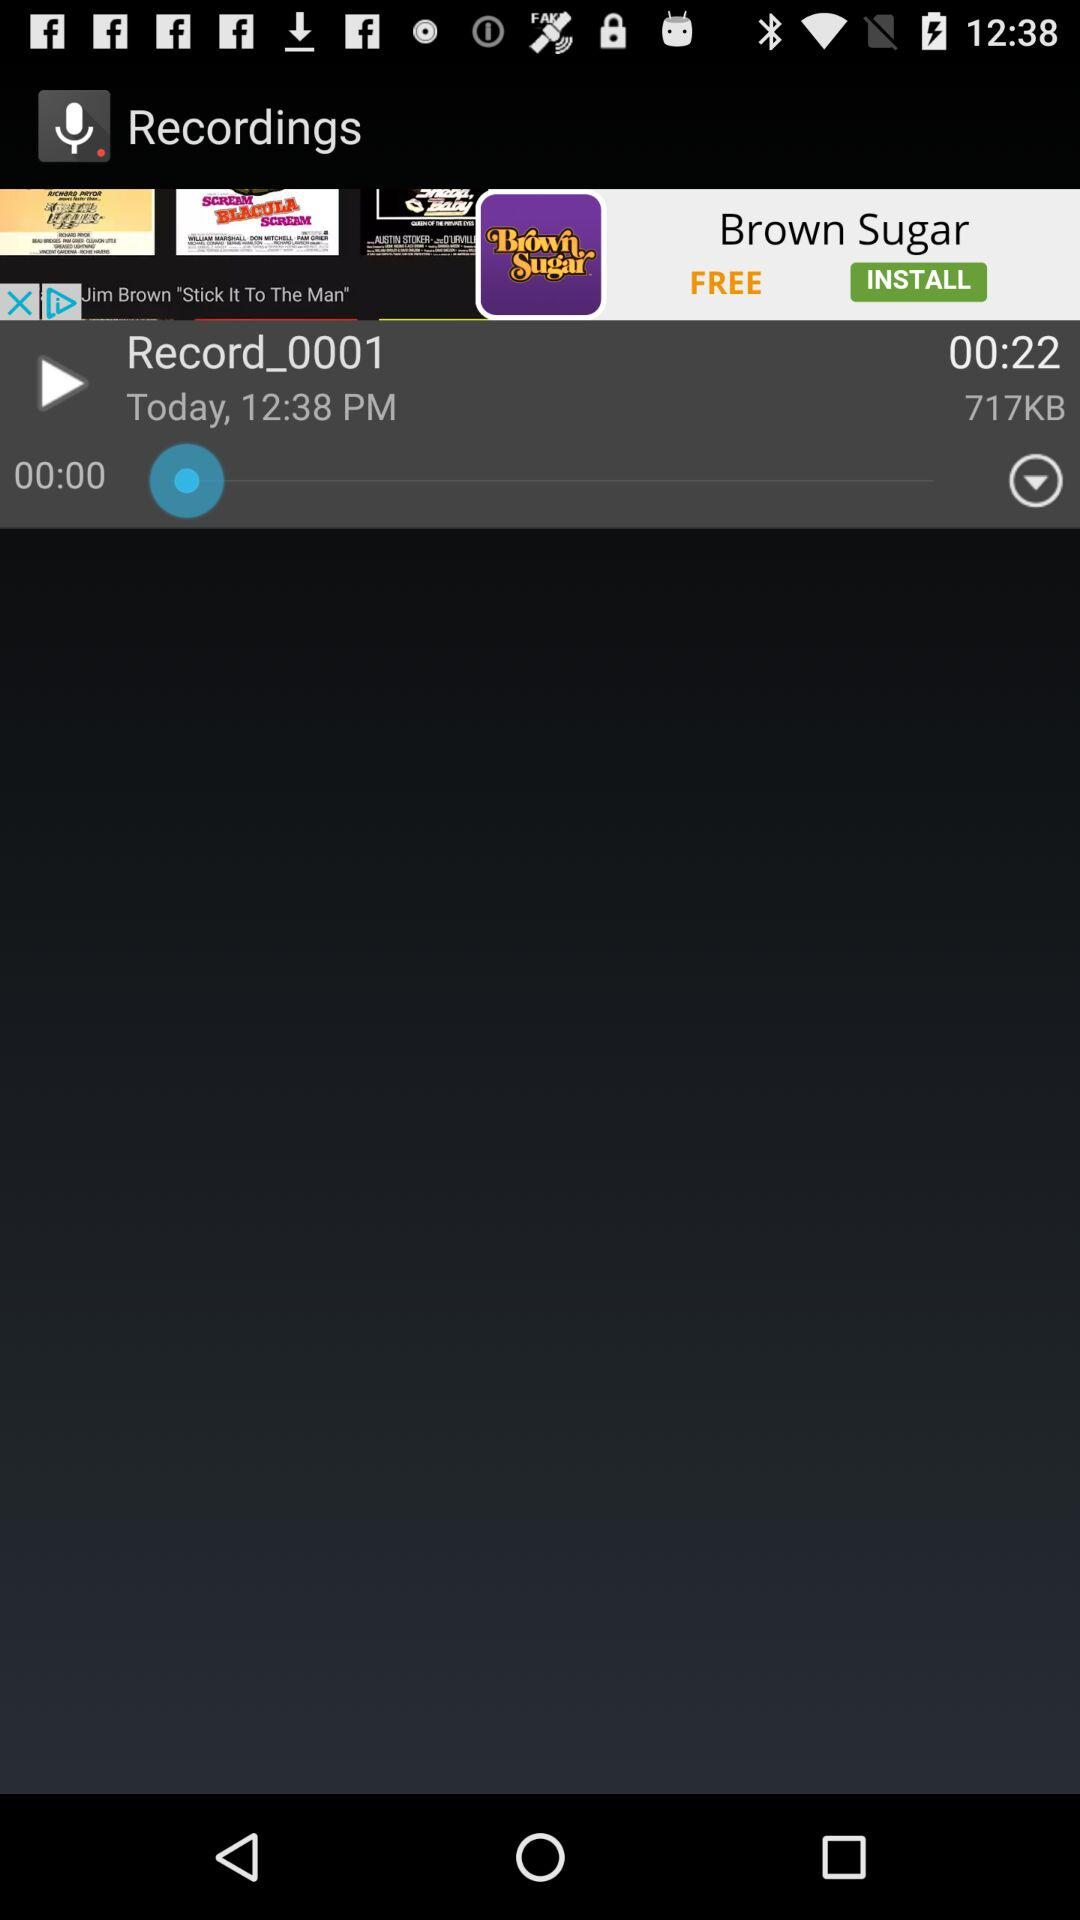How long is the total duration of all the recordings?
Answer the question using a single word or phrase. 00:22 